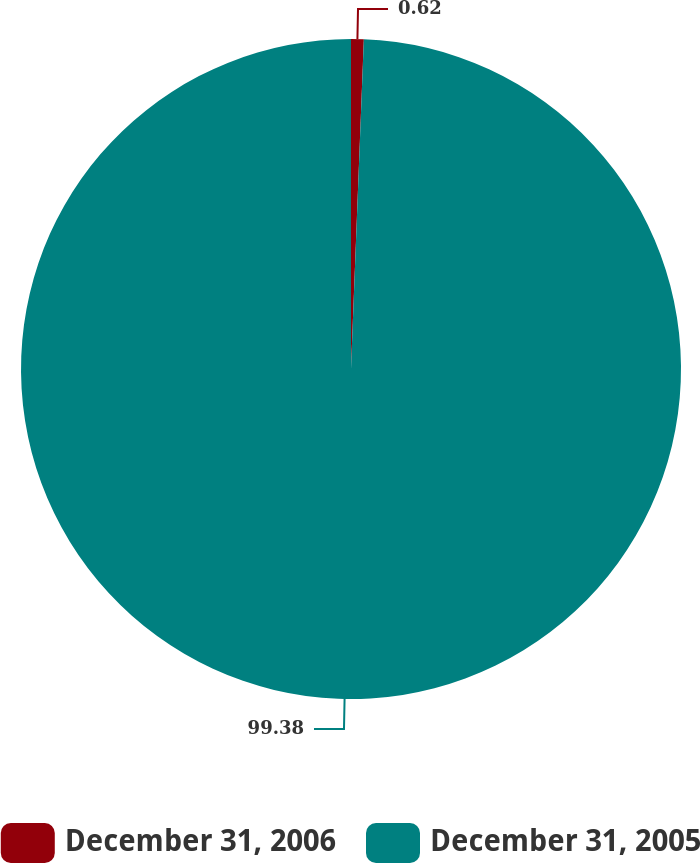<chart> <loc_0><loc_0><loc_500><loc_500><pie_chart><fcel>December 31, 2006<fcel>December 31, 2005<nl><fcel>0.62%<fcel>99.38%<nl></chart> 